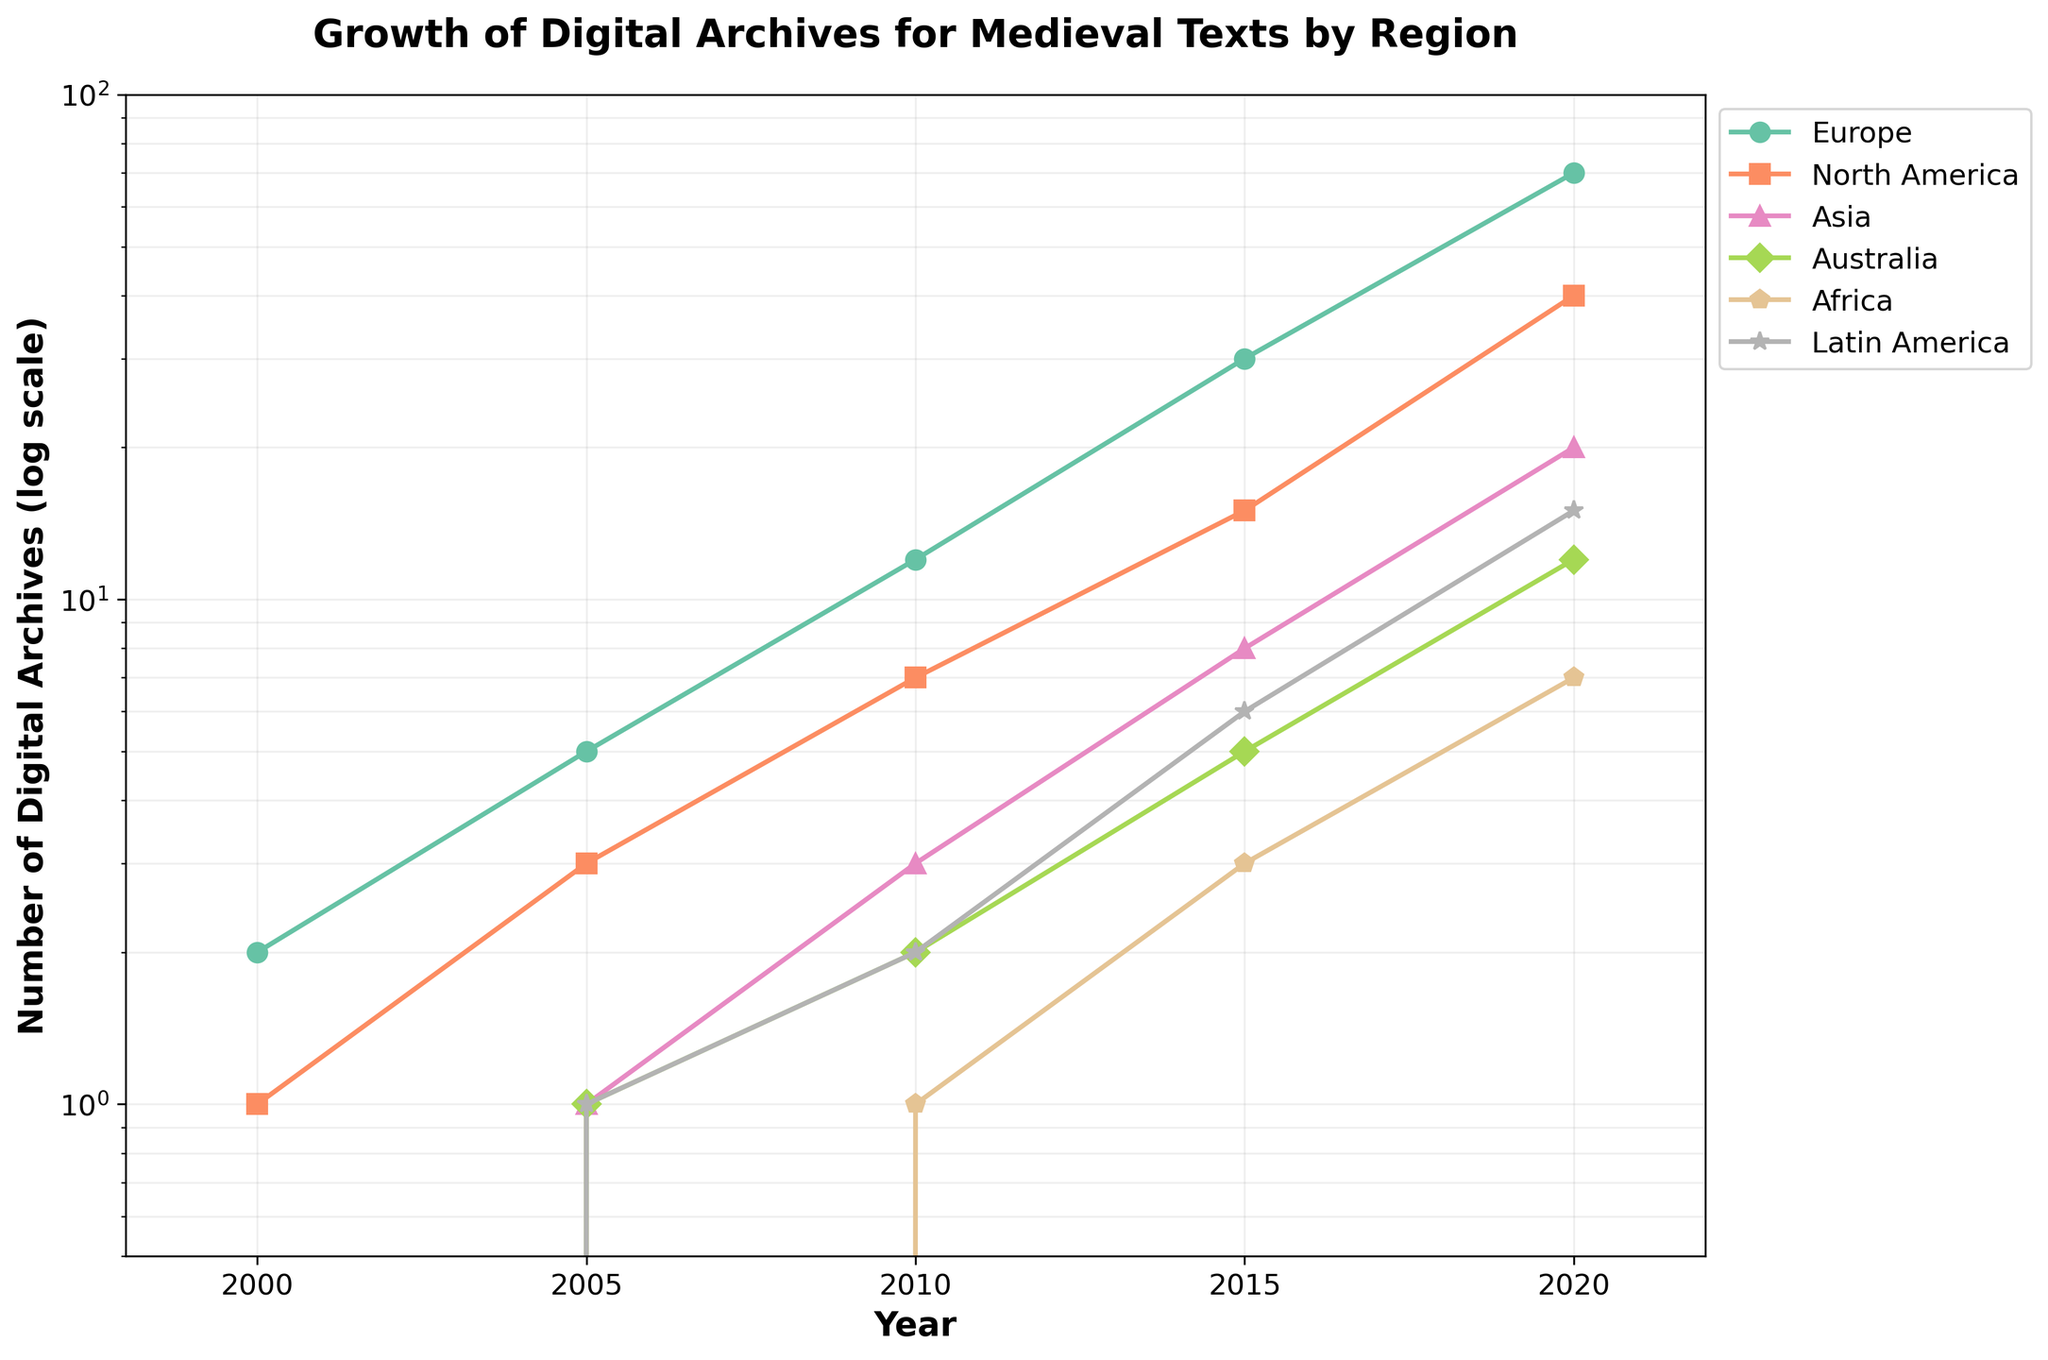What's the title of the figure? The title is displayed at the top of the figure, above the plot area. This information is usually bold and larger in font size compared to other text elements in the figure.
Answer: Growth of Digital Archives for Medieval Texts by Region Which region had the highest number of digital archives in 2020? To find the highest number of digital archives in 2020, look at the end of the lines on the plot, which represent the year 2020, and find the peak among them. Europe has the highest point.
Answer: Europe Between 2015 and 2020, which region had the most significant increase in digital archives? Examine the lines representing different regions between the years 2015 and 2020 on the x-axis, and compare the slopes. Europe shows the steepest upward trend.
Answer: Europe What is the range of the y-axis in the figure? The range of the y-axis can be determined by looking at the minimum and maximum values along the y-axis. The plot uses logarithmic scaling, and the values span from the lowest (0.5) to the highest (100).
Answer: 0.5 to 100 Which two regions had equal numbers of digital archives in the year 2010, and how many archives did they have? Find the data points for the year 2010 on the x-axis. North America and Latin America had equal values, represented by the same height of the data points on the y-axis. Both had 2 digital archives.
Answer: North America and Latin America, 2 archives How many regions had no digital archives recorded in the year 2000? Check the data points corresponding to the year 2000 on the x-axis. Africa, Asia, Australia, and Latin America show 0 digital archives.
Answer: Four regions Which region experienced the earliest growth in digital archives? Look at the starting points of each region on the x-axis. Europe has the earliest growth, starting with 2 digital archives in the year 2000.
Answer: Europe By 2020, how much did the number of digital archives in Latin America increase compared to 2005? Find the points for Latin America for the years 2005 and 2020 on the x-axis and observe the change in the y-axis values. In 2005, Latin America had 1 archive, and in 2020, it had 15. The increase is \(15 - 1 = 14\).
Answer: 14 In the year 2015, which region had the closest number of digital archives to Asia? Locate the data points for the year 2015 on the x-axis. Asia has 8 archives. North America is the closest with 15 archives.
Answer: North America From 2010 to 2015, what was the average growth in digital archives for Europe? Find the number of archives for Europe in 2010 and 2015, which are 12 and 30, respectively. The growth rate is calculated as \( \frac{30 - 12}{5} = 3.6 \) archives per year.
Answer: 3.6 archives per year 